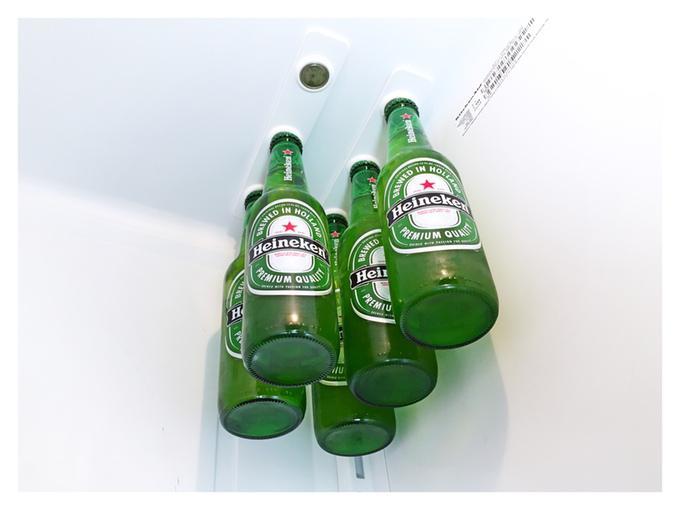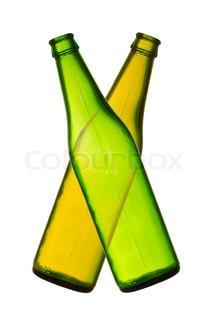The first image is the image on the left, the second image is the image on the right. For the images displayed, is the sentence "An image includes at least one green bottle displayed horizontally." factually correct? Answer yes or no. No. The first image is the image on the left, the second image is the image on the right. Analyze the images presented: Is the assertion "One image includes at least one glass containing beer, along with at least one beer bottle." valid? Answer yes or no. No. The first image is the image on the left, the second image is the image on the right. For the images displayed, is the sentence "In one image, the bottles are capped and have distinctive matching labels, while the other image is of empty, uncapped bottles." factually correct? Answer yes or no. Yes. 